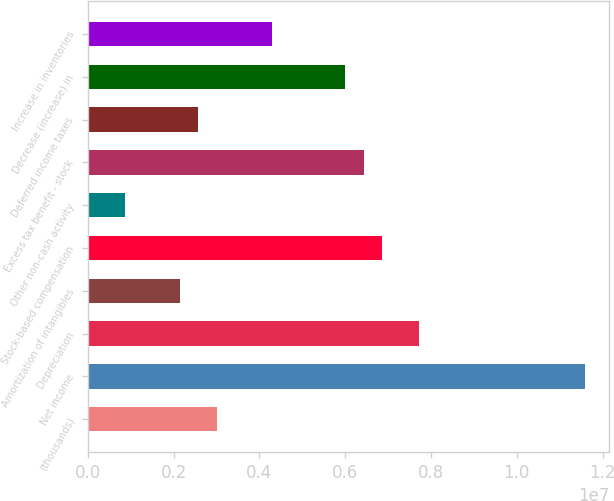<chart> <loc_0><loc_0><loc_500><loc_500><bar_chart><fcel>(thousands)<fcel>Net income<fcel>Depreciation<fcel>Amortization of intangibles<fcel>Stock-based compensation<fcel>Other non-cash activity<fcel>Excess tax benefit - stock<fcel>Deferred income taxes<fcel>Decrease (increase) in<fcel>Increase in inventories<nl><fcel>3.0026e+06<fcel>1.15806e+07<fcel>7.7205e+06<fcel>2.1448e+06<fcel>6.8627e+06<fcel>858103<fcel>6.4338e+06<fcel>2.5737e+06<fcel>6.0049e+06<fcel>4.2893e+06<nl></chart> 